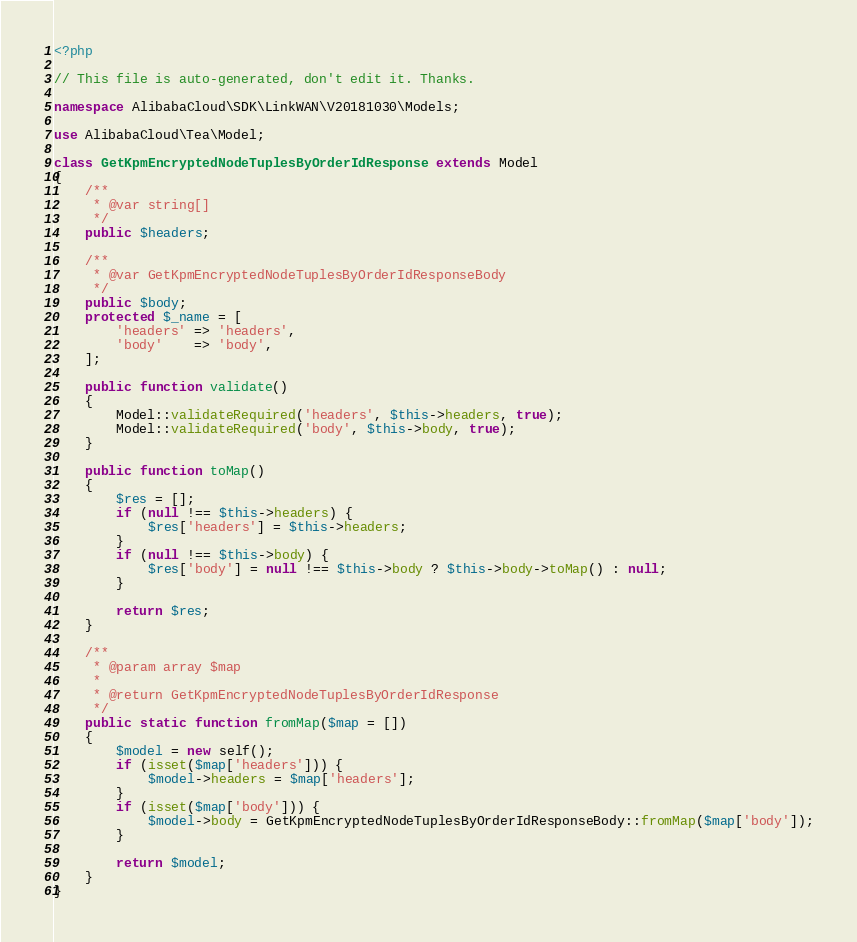<code> <loc_0><loc_0><loc_500><loc_500><_PHP_><?php

// This file is auto-generated, don't edit it. Thanks.

namespace AlibabaCloud\SDK\LinkWAN\V20181030\Models;

use AlibabaCloud\Tea\Model;

class GetKpmEncryptedNodeTuplesByOrderIdResponse extends Model
{
    /**
     * @var string[]
     */
    public $headers;

    /**
     * @var GetKpmEncryptedNodeTuplesByOrderIdResponseBody
     */
    public $body;
    protected $_name = [
        'headers' => 'headers',
        'body'    => 'body',
    ];

    public function validate()
    {
        Model::validateRequired('headers', $this->headers, true);
        Model::validateRequired('body', $this->body, true);
    }

    public function toMap()
    {
        $res = [];
        if (null !== $this->headers) {
            $res['headers'] = $this->headers;
        }
        if (null !== $this->body) {
            $res['body'] = null !== $this->body ? $this->body->toMap() : null;
        }

        return $res;
    }

    /**
     * @param array $map
     *
     * @return GetKpmEncryptedNodeTuplesByOrderIdResponse
     */
    public static function fromMap($map = [])
    {
        $model = new self();
        if (isset($map['headers'])) {
            $model->headers = $map['headers'];
        }
        if (isset($map['body'])) {
            $model->body = GetKpmEncryptedNodeTuplesByOrderIdResponseBody::fromMap($map['body']);
        }

        return $model;
    }
}
</code> 